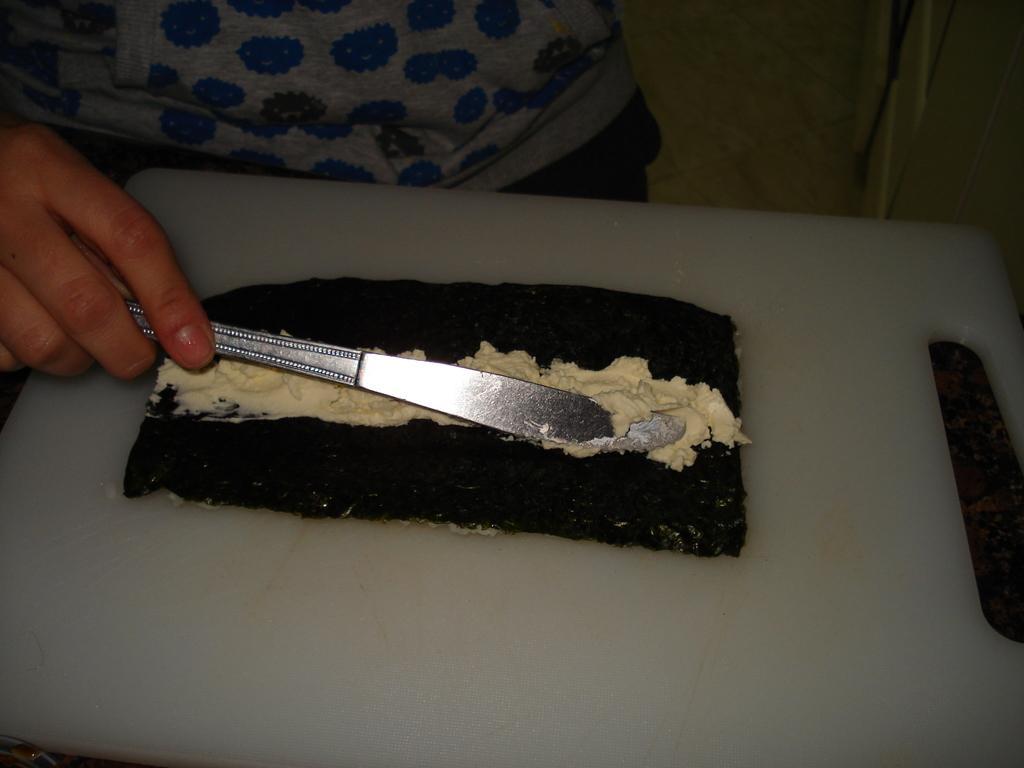Please provide a concise description of this image. In this picture we can see some food items on a cutting board. We can see the hand of a person holding a knife. There are other objects. 